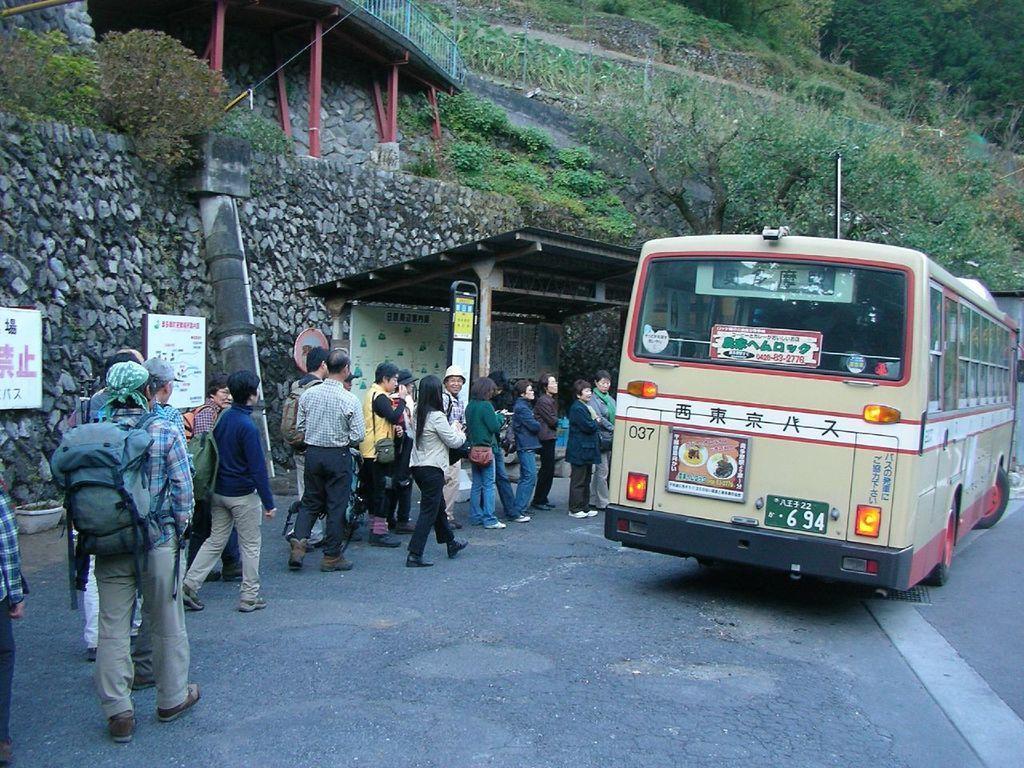Could you give a brief overview of what you see in this image? In this image, we can see a bus. There are some people standing and wearing clothes. There is a shelter in the middle of the image. There is a tree on the right side of the image. 